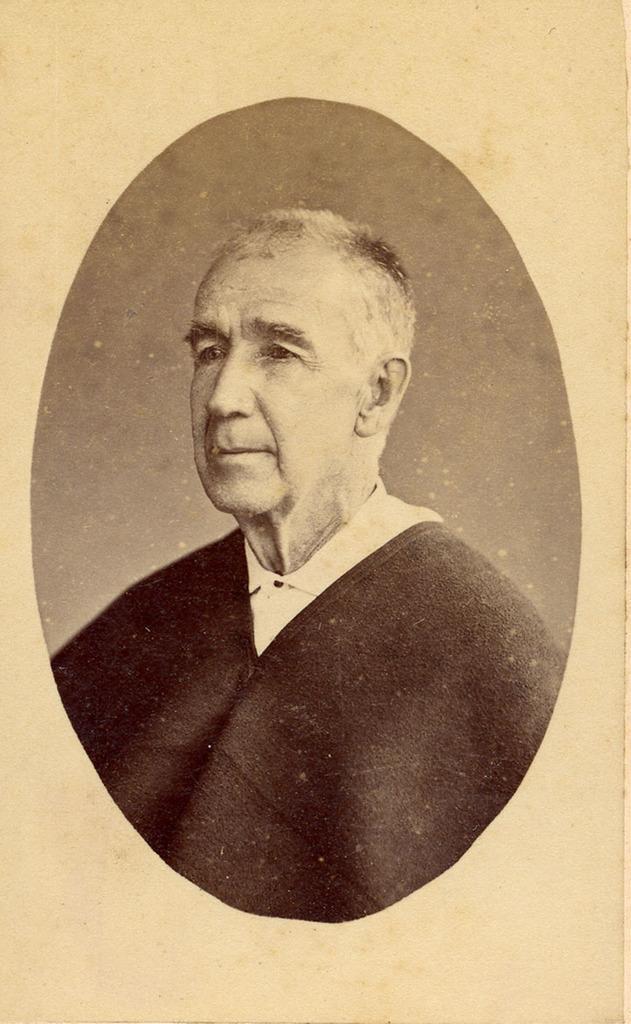In one or two sentences, can you explain what this image depicts? This looks like an old black and white image. I can see the old man in the image. 